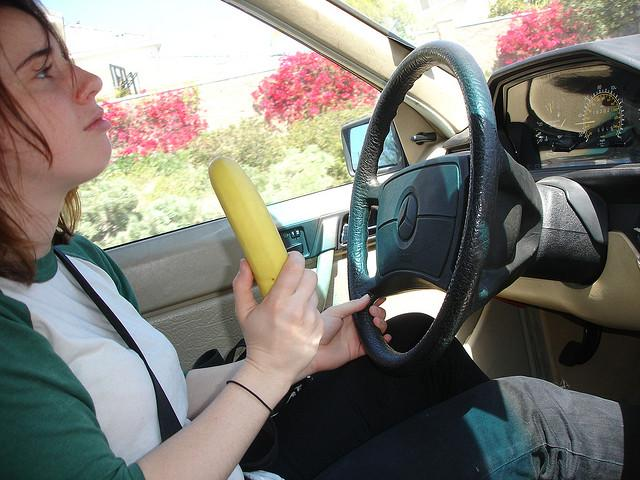Where do bananas originally come from? southeast asia 